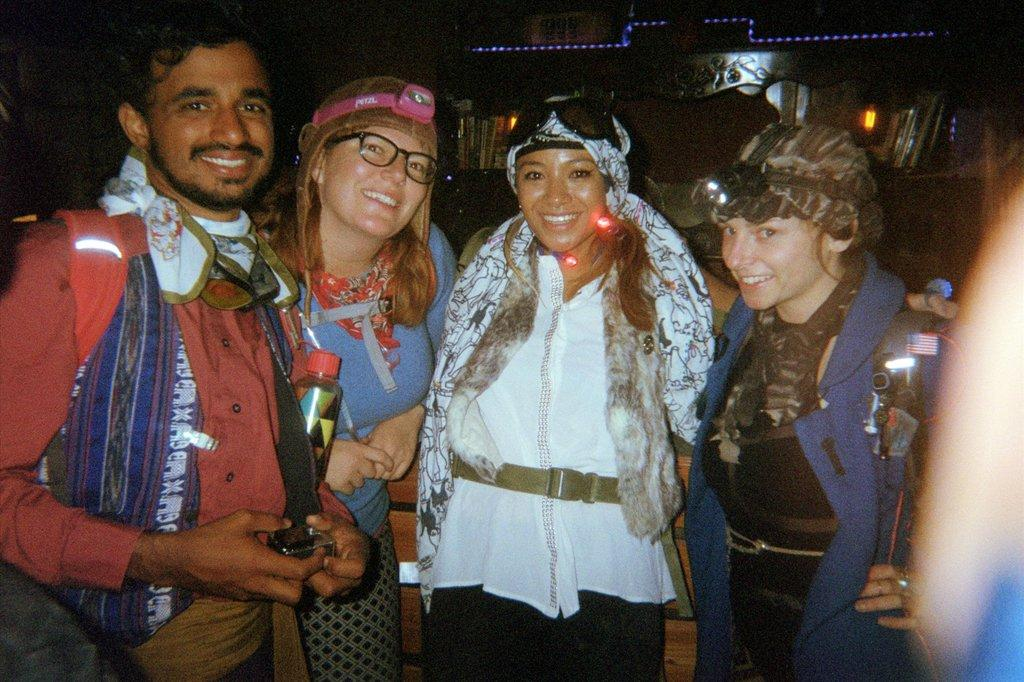How many people are in the image? There is a group of people in the image. What can be observed about the clothing of the people in the image? The people are wearing different color dresses. What object is one person holding in the image? One person is holding a bottle in the image. What can be seen in the image that provides illumination? There are lights visible in the image. What is the color of the background in the image? The background of the image is black. What type of vegetable is being used as a hat by the woman in the image? There is no woman or vegetable present in the image. 